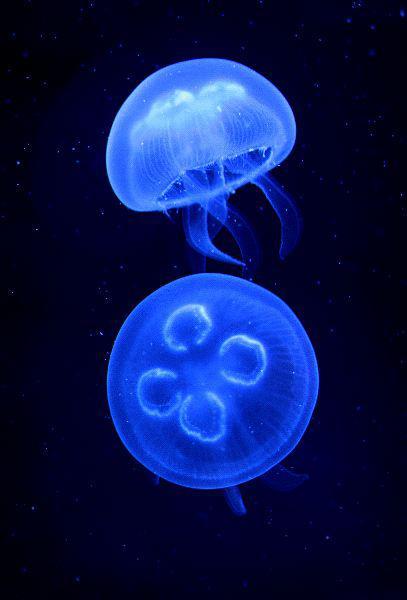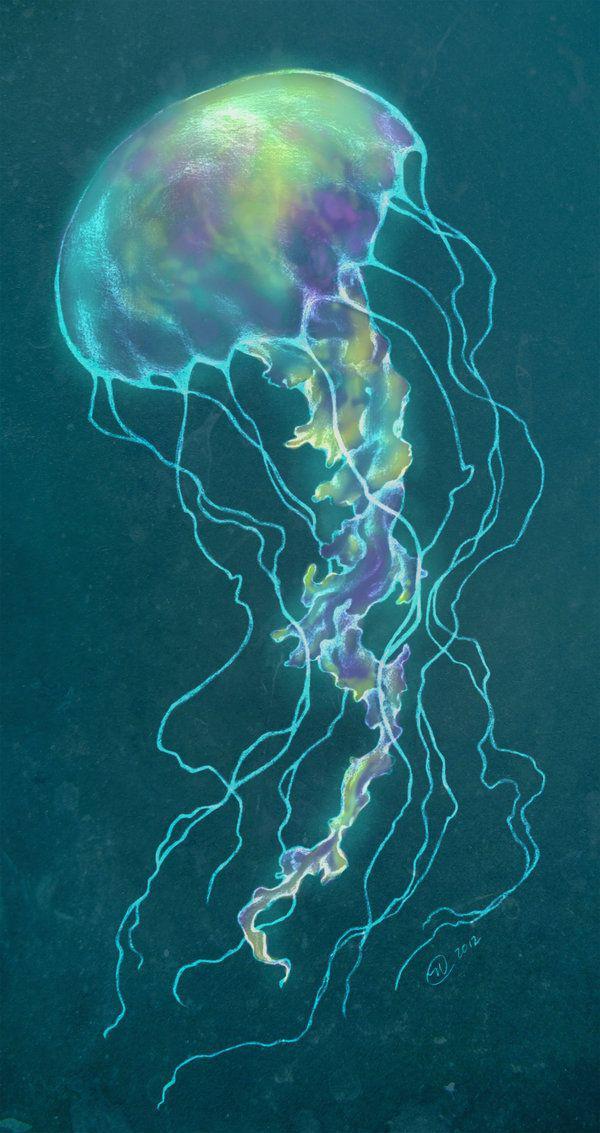The first image is the image on the left, the second image is the image on the right. Given the left and right images, does the statement "The left image shows at least two translucent blue jellyfish with short tentacles and mushroom shapes, and the right image includes a jellyfish with aqua coloring and longer tentacles." hold true? Answer yes or no. Yes. The first image is the image on the left, the second image is the image on the right. Given the left and right images, does the statement "The image on the left shows exactly 3 jellyfish." hold true? Answer yes or no. No. 